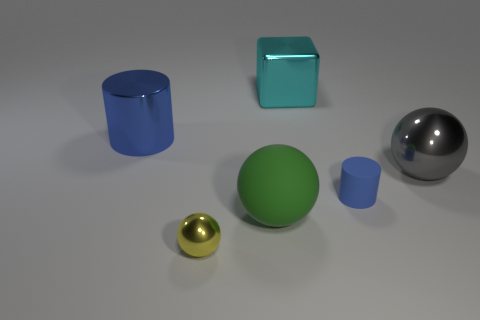Add 4 cyan metal things. How many objects exist? 10 Subtract all cylinders. How many objects are left? 4 Subtract all big green rubber spheres. Subtract all matte objects. How many objects are left? 3 Add 6 big cyan shiny blocks. How many big cyan shiny blocks are left? 7 Add 4 brown rubber cylinders. How many brown rubber cylinders exist? 4 Subtract 0 purple cubes. How many objects are left? 6 